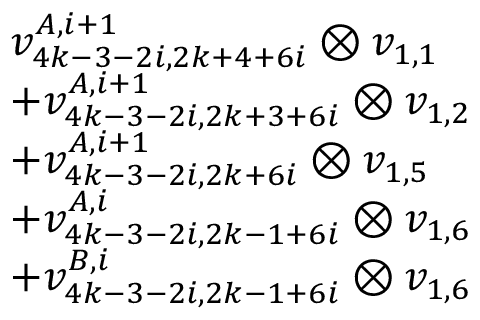<formula> <loc_0><loc_0><loc_500><loc_500>\begin{array} { r l } & { v _ { 4 k - 3 - 2 i , 2 k + 4 + 6 i } ^ { A , i + 1 } \otimes v _ { 1 , 1 } } \\ & { + v _ { 4 k - 3 - 2 i , 2 k + 3 + 6 i } ^ { A , i + 1 } \otimes v _ { 1 , 2 } } \\ & { + v _ { 4 k - 3 - 2 i , 2 k + 6 i } ^ { A , i + 1 } \otimes v _ { 1 , 5 } } \\ & { + v _ { 4 k - 3 - 2 i , 2 k - 1 + 6 i } ^ { A , i } \otimes v _ { 1 , 6 } } \\ & { + v _ { 4 k - 3 - 2 i , 2 k - 1 + 6 i } ^ { B , i } \otimes v _ { 1 , 6 } } \end{array}</formula> 